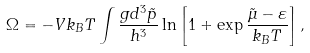Convert formula to latex. <formula><loc_0><loc_0><loc_500><loc_500>\Omega = - V k _ { B } T \int \frac { g d ^ { 3 } \tilde { p } } { h ^ { 3 } } \ln \left [ 1 + \exp \frac { \tilde { \mu } - \varepsilon } { k _ { B } T } \right ] ,</formula> 